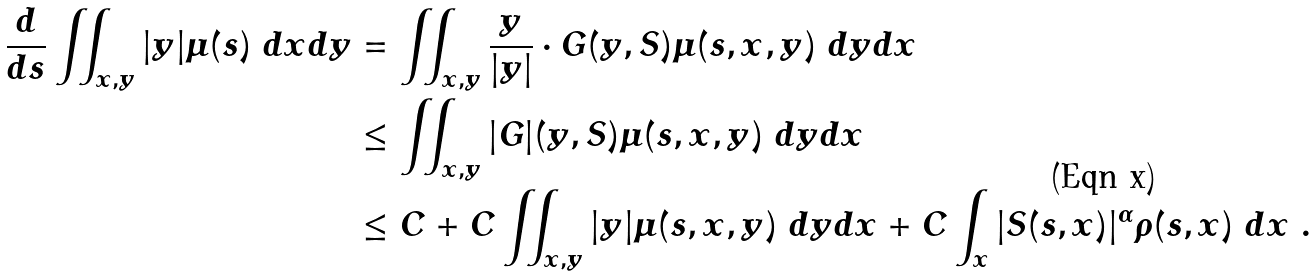Convert formula to latex. <formula><loc_0><loc_0><loc_500><loc_500>\frac { d } { d s } \iint _ { x , y } | y | \mu ( s ) \ d x d y & = \iint _ { x , y } \frac { y } { | y | } \cdot G ( y , S ) \mu ( s , x , y ) \ d y d x \\ & \leq \iint _ { x , y } | G | ( y , S ) \mu ( s , x , y ) \ d y d x \\ & \leq C + C \iint _ { x , y } | y | \mu ( s , x , y ) \ d y d x + C \int _ { x } | S ( s , x ) | ^ { \alpha } \rho ( s , x ) \ d x \ .</formula> 